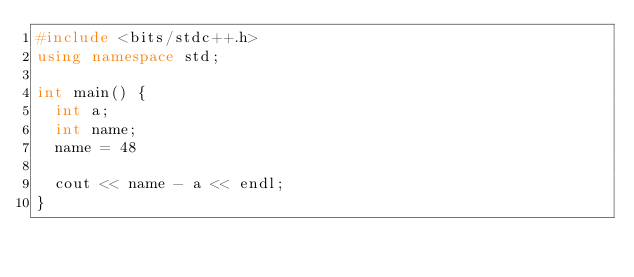Convert code to text. <code><loc_0><loc_0><loc_500><loc_500><_C++_>#include <bits/stdc++.h>
using namespace std;

int main() {
  int a;
  int name;
  name = 48
  
  cout << name - a << endl;
}</code> 